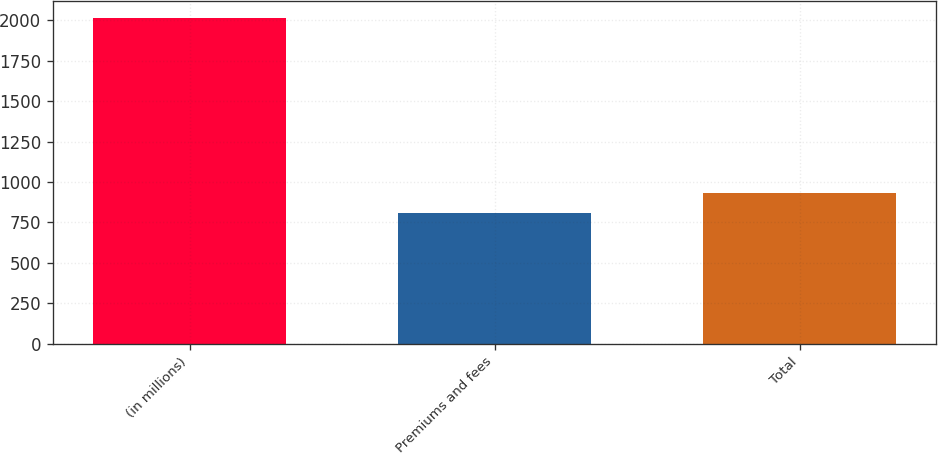Convert chart to OTSL. <chart><loc_0><loc_0><loc_500><loc_500><bar_chart><fcel>(in millions)<fcel>Premiums and fees<fcel>Total<nl><fcel>2016<fcel>809<fcel>929.7<nl></chart> 